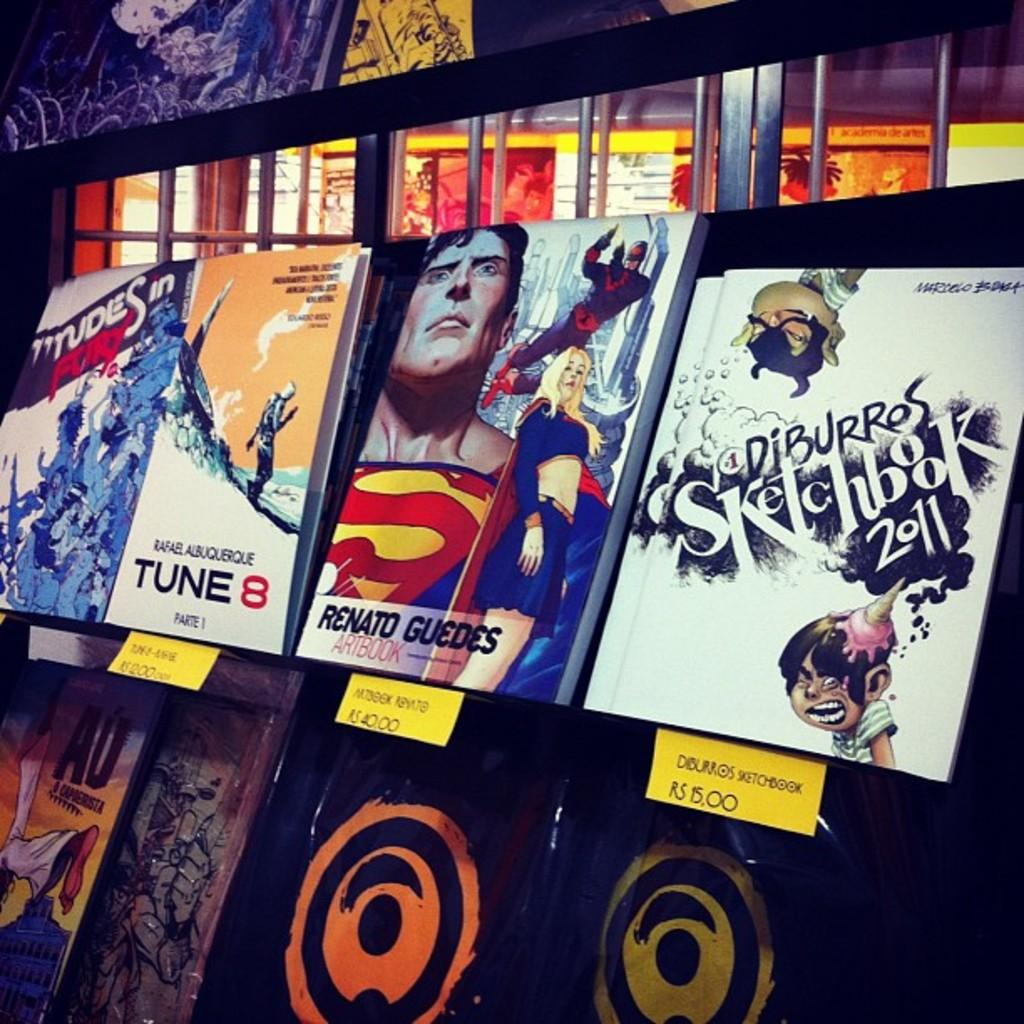<image>
Relay a brief, clear account of the picture shown. Renato Guedes Artbook showing superheroes on the cover between other sketchbooks. 